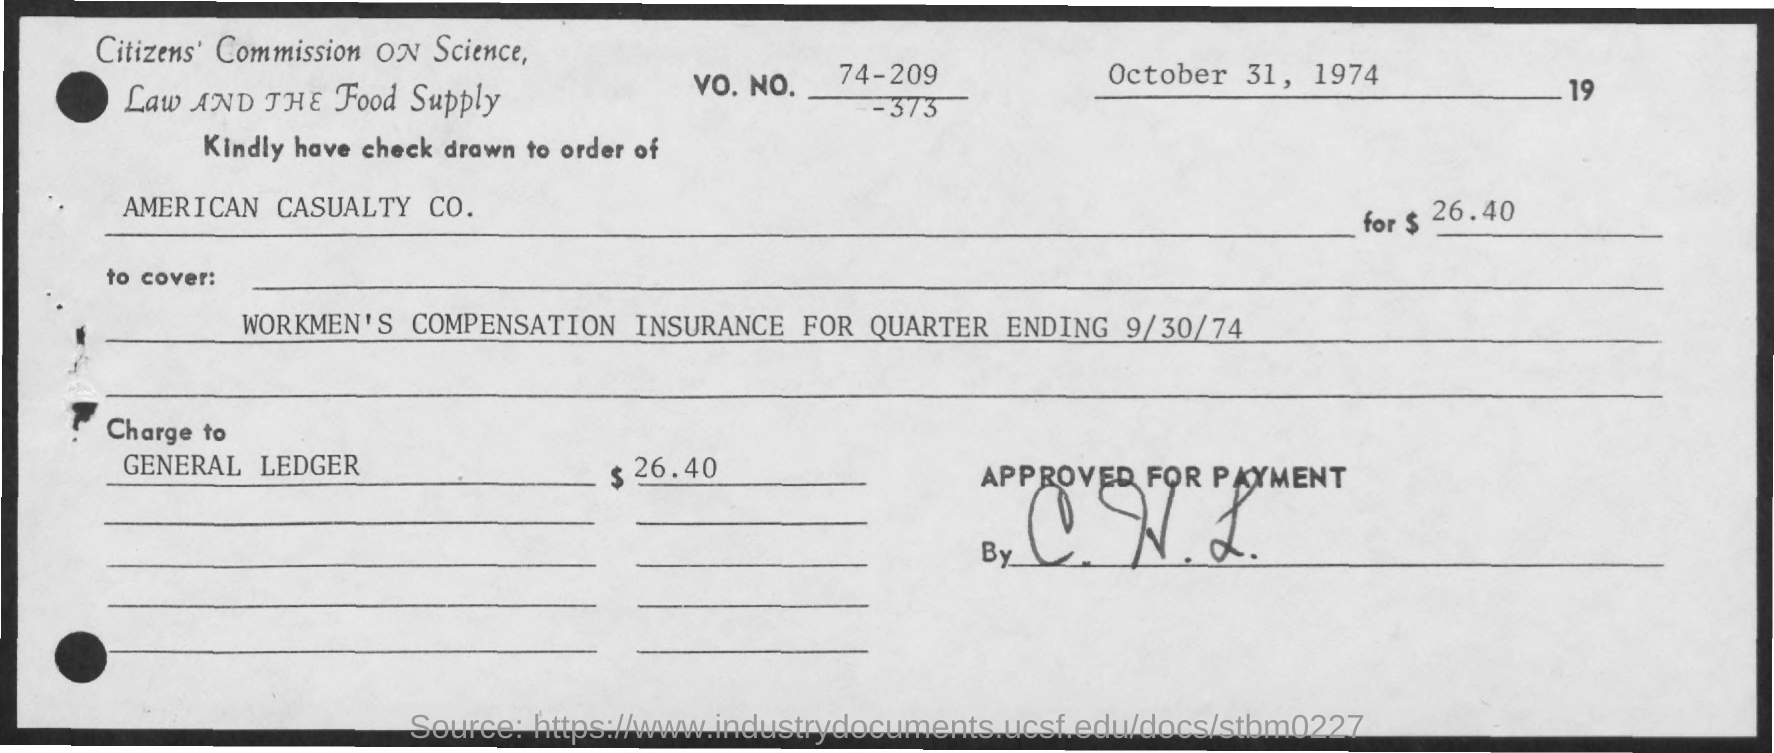What is amount mentioned?
Offer a terse response. $26.40. 